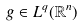Convert formula to latex. <formula><loc_0><loc_0><loc_500><loc_500>g \in L ^ { q } ( \mathbb { R } ^ { n } )</formula> 